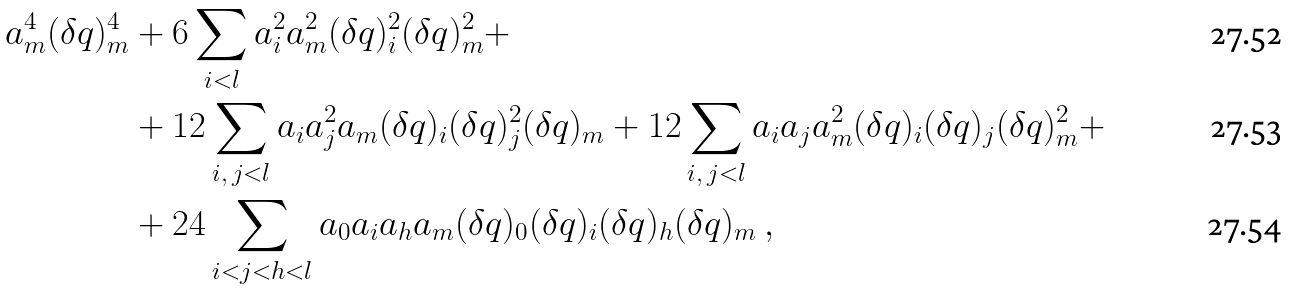Convert formula to latex. <formula><loc_0><loc_0><loc_500><loc_500>a _ { m } ^ { 4 } ( \delta q ) _ { m } ^ { 4 } & + 6 \sum _ { i < l } a _ { i } ^ { 2 } a _ { m } ^ { 2 } ( \delta q ) _ { i } ^ { 2 } ( \delta q ) _ { m } ^ { 2 } + \\ & + 1 2 \sum _ { i , \, j < l } a _ { i } a _ { j } ^ { 2 } a _ { m } ( \delta q ) _ { i } ( \delta q ) _ { j } ^ { 2 } ( \delta q ) _ { m } + 1 2 \sum _ { i , \, j < l } a _ { i } a _ { j } a _ { m } ^ { 2 } ( \delta q ) _ { i } ( \delta q ) _ { j } ( \delta q ) _ { m } ^ { 2 } + \\ & + 2 4 \sum _ { i < j < h < l } a _ { 0 } a _ { i } a _ { h } a _ { m } ( \delta q ) _ { 0 } ( \delta q ) _ { i } ( \delta q ) _ { h } ( \delta q ) _ { m } \ ,</formula> 